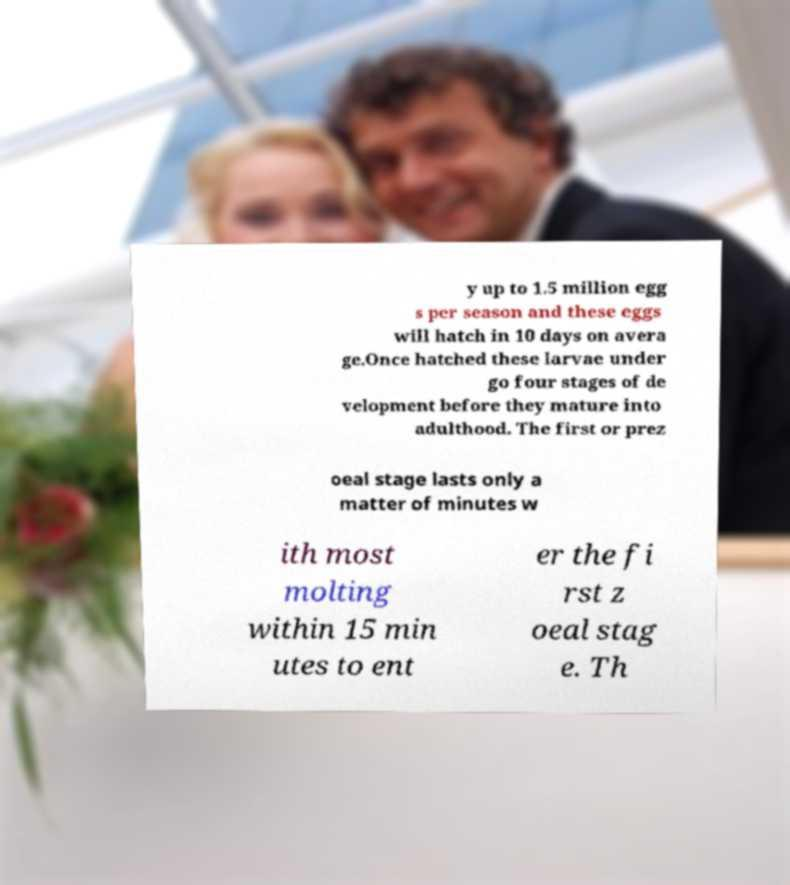There's text embedded in this image that I need extracted. Can you transcribe it verbatim? y up to 1.5 million egg s per season and these eggs will hatch in 10 days on avera ge.Once hatched these larvae under go four stages of de velopment before they mature into adulthood. The first or prez oeal stage lasts only a matter of minutes w ith most molting within 15 min utes to ent er the fi rst z oeal stag e. Th 